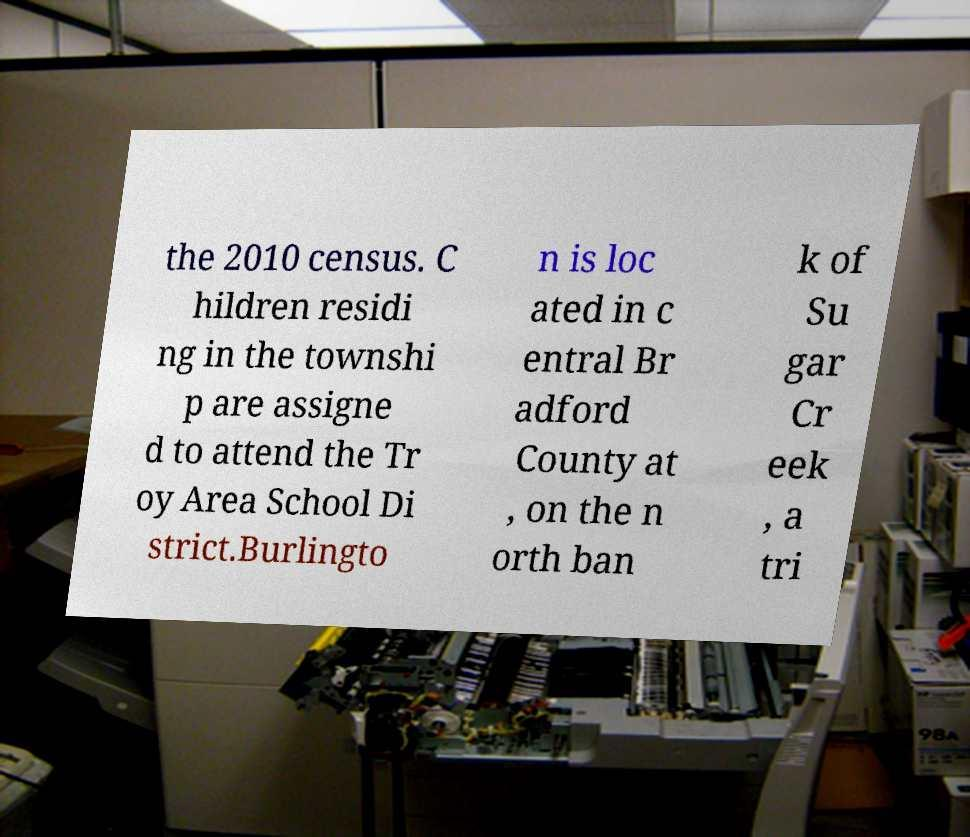I need the written content from this picture converted into text. Can you do that? the 2010 census. C hildren residi ng in the townshi p are assigne d to attend the Tr oy Area School Di strict.Burlingto n is loc ated in c entral Br adford County at , on the n orth ban k of Su gar Cr eek , a tri 